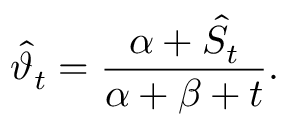<formula> <loc_0><loc_0><loc_500><loc_500>\widehat { \vartheta } _ { t } = \frac { \alpha + \hat { S } _ { t } } { \alpha + \beta + t } .</formula> 